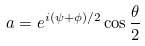<formula> <loc_0><loc_0><loc_500><loc_500>a = e ^ { i ( \psi + \phi ) / 2 } \cos \frac { \theta } { 2 }</formula> 